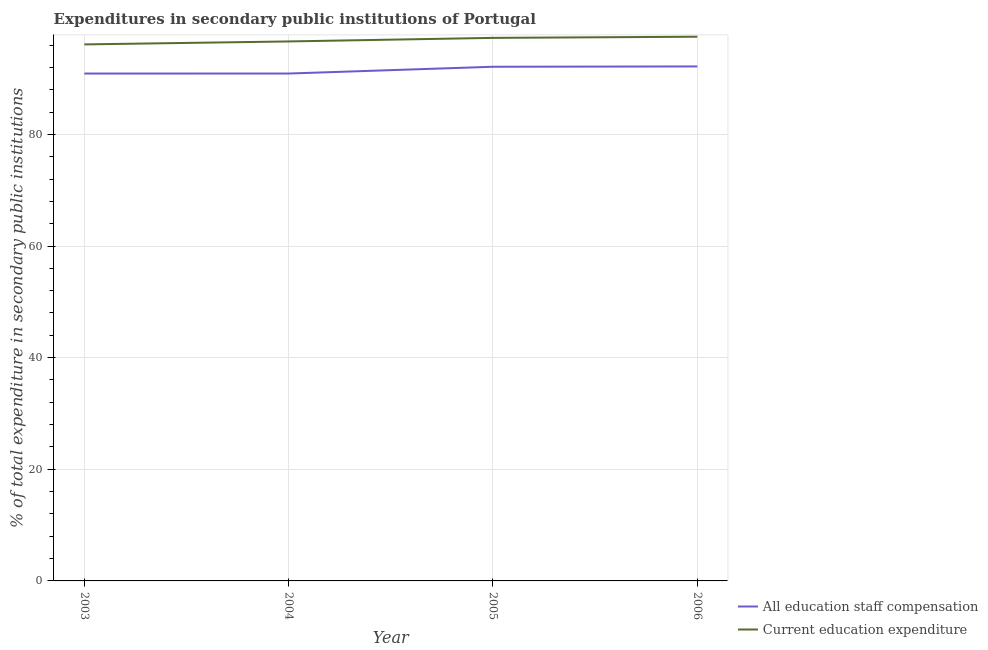What is the expenditure in education in 2005?
Provide a succinct answer. 97.29. Across all years, what is the maximum expenditure in staff compensation?
Keep it short and to the point. 92.17. Across all years, what is the minimum expenditure in education?
Provide a short and direct response. 96.12. In which year was the expenditure in staff compensation maximum?
Your answer should be very brief. 2006. What is the total expenditure in education in the graph?
Give a very brief answer. 387.55. What is the difference between the expenditure in staff compensation in 2003 and that in 2004?
Provide a succinct answer. -0. What is the difference between the expenditure in education in 2004 and the expenditure in staff compensation in 2005?
Provide a short and direct response. 4.53. What is the average expenditure in staff compensation per year?
Your answer should be very brief. 91.52. In the year 2003, what is the difference between the expenditure in education and expenditure in staff compensation?
Give a very brief answer. 5.22. In how many years, is the expenditure in staff compensation greater than 40 %?
Ensure brevity in your answer.  4. What is the ratio of the expenditure in education in 2003 to that in 2005?
Your answer should be very brief. 0.99. Is the expenditure in education in 2004 less than that in 2006?
Your answer should be very brief. Yes. Is the difference between the expenditure in education in 2004 and 2006 greater than the difference between the expenditure in staff compensation in 2004 and 2006?
Provide a short and direct response. Yes. What is the difference between the highest and the second highest expenditure in staff compensation?
Make the answer very short. 0.06. What is the difference between the highest and the lowest expenditure in staff compensation?
Ensure brevity in your answer.  1.27. In how many years, is the expenditure in staff compensation greater than the average expenditure in staff compensation taken over all years?
Your answer should be very brief. 2. Is the expenditure in staff compensation strictly greater than the expenditure in education over the years?
Make the answer very short. No. Is the expenditure in staff compensation strictly less than the expenditure in education over the years?
Provide a short and direct response. Yes. How many years are there in the graph?
Make the answer very short. 4. Are the values on the major ticks of Y-axis written in scientific E-notation?
Your response must be concise. No. What is the title of the graph?
Provide a succinct answer. Expenditures in secondary public institutions of Portugal. What is the label or title of the Y-axis?
Offer a very short reply. % of total expenditure in secondary public institutions. What is the % of total expenditure in secondary public institutions in All education staff compensation in 2003?
Provide a succinct answer. 90.9. What is the % of total expenditure in secondary public institutions in Current education expenditure in 2003?
Offer a terse response. 96.12. What is the % of total expenditure in secondary public institutions of All education staff compensation in 2004?
Your answer should be very brief. 90.9. What is the % of total expenditure in secondary public institutions of Current education expenditure in 2004?
Ensure brevity in your answer.  96.65. What is the % of total expenditure in secondary public institutions in All education staff compensation in 2005?
Make the answer very short. 92.12. What is the % of total expenditure in secondary public institutions in Current education expenditure in 2005?
Provide a succinct answer. 97.29. What is the % of total expenditure in secondary public institutions of All education staff compensation in 2006?
Provide a short and direct response. 92.17. What is the % of total expenditure in secondary public institutions of Current education expenditure in 2006?
Your answer should be very brief. 97.5. Across all years, what is the maximum % of total expenditure in secondary public institutions in All education staff compensation?
Your answer should be very brief. 92.17. Across all years, what is the maximum % of total expenditure in secondary public institutions in Current education expenditure?
Your answer should be compact. 97.5. Across all years, what is the minimum % of total expenditure in secondary public institutions of All education staff compensation?
Your response must be concise. 90.9. Across all years, what is the minimum % of total expenditure in secondary public institutions of Current education expenditure?
Provide a succinct answer. 96.12. What is the total % of total expenditure in secondary public institutions in All education staff compensation in the graph?
Your answer should be compact. 366.08. What is the total % of total expenditure in secondary public institutions in Current education expenditure in the graph?
Ensure brevity in your answer.  387.55. What is the difference between the % of total expenditure in secondary public institutions in All education staff compensation in 2003 and that in 2004?
Give a very brief answer. -0. What is the difference between the % of total expenditure in secondary public institutions in Current education expenditure in 2003 and that in 2004?
Your response must be concise. -0.53. What is the difference between the % of total expenditure in secondary public institutions of All education staff compensation in 2003 and that in 2005?
Offer a very short reply. -1.22. What is the difference between the % of total expenditure in secondary public institutions in Current education expenditure in 2003 and that in 2005?
Make the answer very short. -1.17. What is the difference between the % of total expenditure in secondary public institutions in All education staff compensation in 2003 and that in 2006?
Provide a short and direct response. -1.27. What is the difference between the % of total expenditure in secondary public institutions in Current education expenditure in 2003 and that in 2006?
Your response must be concise. -1.38. What is the difference between the % of total expenditure in secondary public institutions in All education staff compensation in 2004 and that in 2005?
Your response must be concise. -1.22. What is the difference between the % of total expenditure in secondary public institutions in Current education expenditure in 2004 and that in 2005?
Your answer should be very brief. -0.64. What is the difference between the % of total expenditure in secondary public institutions in All education staff compensation in 2004 and that in 2006?
Provide a succinct answer. -1.27. What is the difference between the % of total expenditure in secondary public institutions of Current education expenditure in 2004 and that in 2006?
Offer a very short reply. -0.85. What is the difference between the % of total expenditure in secondary public institutions in All education staff compensation in 2005 and that in 2006?
Make the answer very short. -0.06. What is the difference between the % of total expenditure in secondary public institutions in Current education expenditure in 2005 and that in 2006?
Keep it short and to the point. -0.21. What is the difference between the % of total expenditure in secondary public institutions in All education staff compensation in 2003 and the % of total expenditure in secondary public institutions in Current education expenditure in 2004?
Keep it short and to the point. -5.75. What is the difference between the % of total expenditure in secondary public institutions in All education staff compensation in 2003 and the % of total expenditure in secondary public institutions in Current education expenditure in 2005?
Keep it short and to the point. -6.39. What is the difference between the % of total expenditure in secondary public institutions of All education staff compensation in 2003 and the % of total expenditure in secondary public institutions of Current education expenditure in 2006?
Keep it short and to the point. -6.6. What is the difference between the % of total expenditure in secondary public institutions of All education staff compensation in 2004 and the % of total expenditure in secondary public institutions of Current education expenditure in 2005?
Offer a terse response. -6.39. What is the difference between the % of total expenditure in secondary public institutions of All education staff compensation in 2004 and the % of total expenditure in secondary public institutions of Current education expenditure in 2006?
Offer a terse response. -6.6. What is the difference between the % of total expenditure in secondary public institutions of All education staff compensation in 2005 and the % of total expenditure in secondary public institutions of Current education expenditure in 2006?
Offer a terse response. -5.38. What is the average % of total expenditure in secondary public institutions in All education staff compensation per year?
Keep it short and to the point. 91.52. What is the average % of total expenditure in secondary public institutions of Current education expenditure per year?
Provide a short and direct response. 96.89. In the year 2003, what is the difference between the % of total expenditure in secondary public institutions in All education staff compensation and % of total expenditure in secondary public institutions in Current education expenditure?
Offer a very short reply. -5.22. In the year 2004, what is the difference between the % of total expenditure in secondary public institutions of All education staff compensation and % of total expenditure in secondary public institutions of Current education expenditure?
Your answer should be compact. -5.75. In the year 2005, what is the difference between the % of total expenditure in secondary public institutions of All education staff compensation and % of total expenditure in secondary public institutions of Current education expenditure?
Make the answer very short. -5.17. In the year 2006, what is the difference between the % of total expenditure in secondary public institutions in All education staff compensation and % of total expenditure in secondary public institutions in Current education expenditure?
Offer a terse response. -5.32. What is the ratio of the % of total expenditure in secondary public institutions of All education staff compensation in 2003 to that in 2004?
Your answer should be compact. 1. What is the ratio of the % of total expenditure in secondary public institutions in Current education expenditure in 2003 to that in 2004?
Ensure brevity in your answer.  0.99. What is the ratio of the % of total expenditure in secondary public institutions of All education staff compensation in 2003 to that in 2006?
Offer a very short reply. 0.99. What is the ratio of the % of total expenditure in secondary public institutions in Current education expenditure in 2003 to that in 2006?
Your answer should be compact. 0.99. What is the ratio of the % of total expenditure in secondary public institutions in All education staff compensation in 2004 to that in 2006?
Offer a very short reply. 0.99. What is the ratio of the % of total expenditure in secondary public institutions in Current education expenditure in 2004 to that in 2006?
Make the answer very short. 0.99. What is the ratio of the % of total expenditure in secondary public institutions in Current education expenditure in 2005 to that in 2006?
Make the answer very short. 1. What is the difference between the highest and the second highest % of total expenditure in secondary public institutions of All education staff compensation?
Ensure brevity in your answer.  0.06. What is the difference between the highest and the second highest % of total expenditure in secondary public institutions of Current education expenditure?
Keep it short and to the point. 0.21. What is the difference between the highest and the lowest % of total expenditure in secondary public institutions in All education staff compensation?
Your answer should be very brief. 1.27. What is the difference between the highest and the lowest % of total expenditure in secondary public institutions of Current education expenditure?
Make the answer very short. 1.38. 